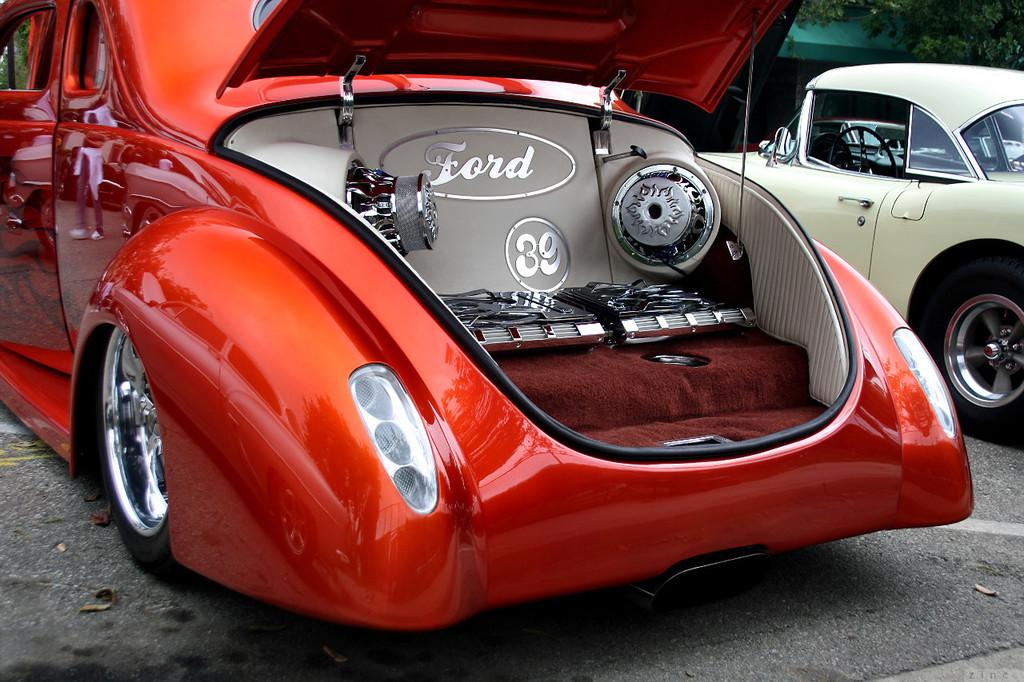<image>
Present a compact description of the photo's key features. Car with the trunk open showing the word ford and speakers 